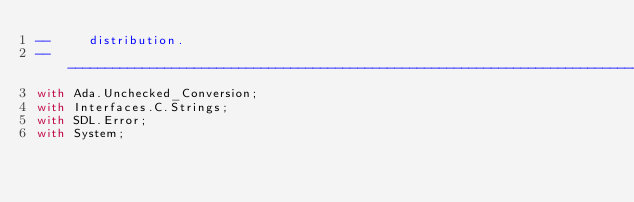Convert code to text. <code><loc_0><loc_0><loc_500><loc_500><_Ada_>--     distribution.
--------------------------------------------------------------------------------------------------------------------
with Ada.Unchecked_Conversion;
with Interfaces.C.Strings;
with SDL.Error;
with System;
</code> 